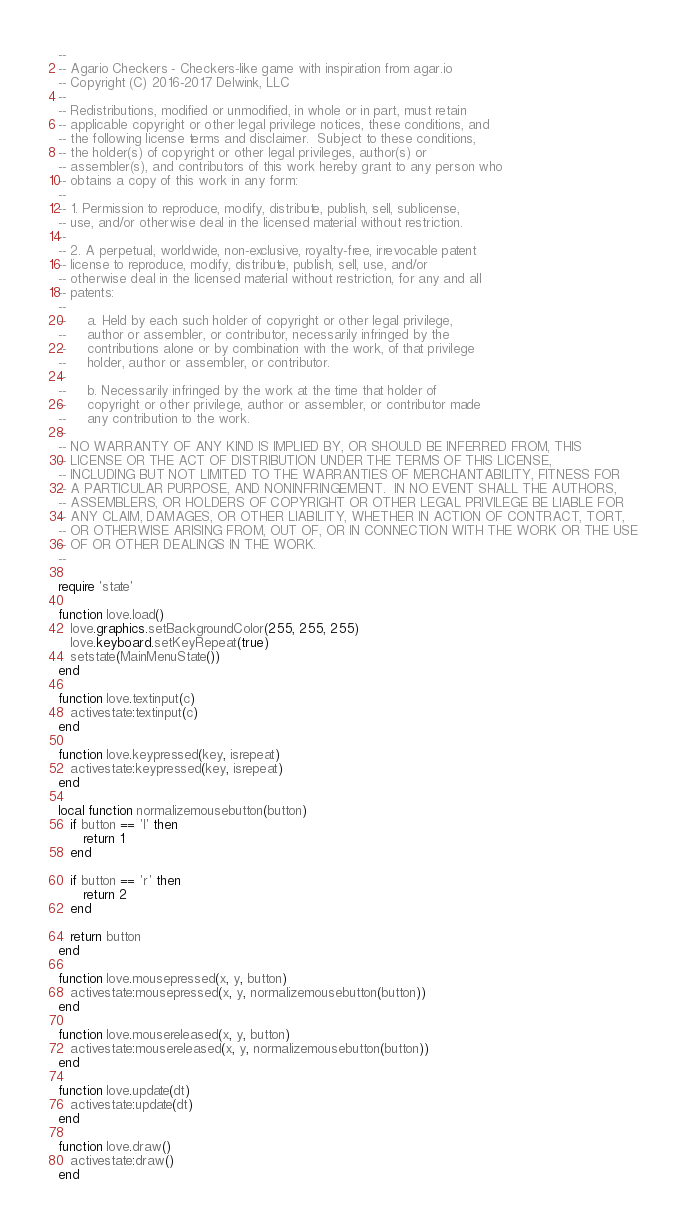Convert code to text. <code><loc_0><loc_0><loc_500><loc_500><_Lua_>--
-- Agario Checkers - Checkers-like game with inspiration from agar.io
-- Copyright (C) 2016-2017 Delwink, LLC
--
-- Redistributions, modified or unmodified, in whole or in part, must retain
-- applicable copyright or other legal privilege notices, these conditions, and
-- the following license terms and disclaimer.  Subject to these conditions,
-- the holder(s) of copyright or other legal privileges, author(s) or
-- assembler(s), and contributors of this work hereby grant to any person who
-- obtains a copy of this work in any form:
--
-- 1. Permission to reproduce, modify, distribute, publish, sell, sublicense,
-- use, and/or otherwise deal in the licensed material without restriction.
--
-- 2. A perpetual, worldwide, non-exclusive, royalty-free, irrevocable patent
-- license to reproduce, modify, distribute, publish, sell, use, and/or
-- otherwise deal in the licensed material without restriction, for any and all
-- patents:
--
--     a. Held by each such holder of copyright or other legal privilege,
--     author or assembler, or contributor, necessarily infringed by the
--     contributions alone or by combination with the work, of that privilege
--     holder, author or assembler, or contributor.
--
--     b. Necessarily infringed by the work at the time that holder of
--     copyright or other privilege, author or assembler, or contributor made
--     any contribution to the work.
--
-- NO WARRANTY OF ANY KIND IS IMPLIED BY, OR SHOULD BE INFERRED FROM, THIS
-- LICENSE OR THE ACT OF DISTRIBUTION UNDER THE TERMS OF THIS LICENSE,
-- INCLUDING BUT NOT LIMITED TO THE WARRANTIES OF MERCHANTABILITY, FITNESS FOR
-- A PARTICULAR PURPOSE, AND NONINFRINGEMENT.  IN NO EVENT SHALL THE AUTHORS,
-- ASSEMBLERS, OR HOLDERS OF COPYRIGHT OR OTHER LEGAL PRIVILEGE BE LIABLE FOR
-- ANY CLAIM, DAMAGES, OR OTHER LIABILITY, WHETHER IN ACTION OF CONTRACT, TORT,
-- OR OTHERWISE ARISING FROM, OUT OF, OR IN CONNECTION WITH THE WORK OR THE USE
-- OF OR OTHER DEALINGS IN THE WORK.
--

require 'state'

function love.load()
   love.graphics.setBackgroundColor(255, 255, 255)
   love.keyboard.setKeyRepeat(true)
   setstate(MainMenuState())
end

function love.textinput(c)
   activestate:textinput(c)
end

function love.keypressed(key, isrepeat)
   activestate:keypressed(key, isrepeat)
end

local function normalizemousebutton(button)
   if button == 'l' then
      return 1
   end

   if button == 'r' then
      return 2
   end

   return button
end

function love.mousepressed(x, y, button)
   activestate:mousepressed(x, y, normalizemousebutton(button))
end

function love.mousereleased(x, y, button)
   activestate:mousereleased(x, y, normalizemousebutton(button))
end

function love.update(dt)
   activestate:update(dt)
end

function love.draw()
   activestate:draw()
end
</code> 